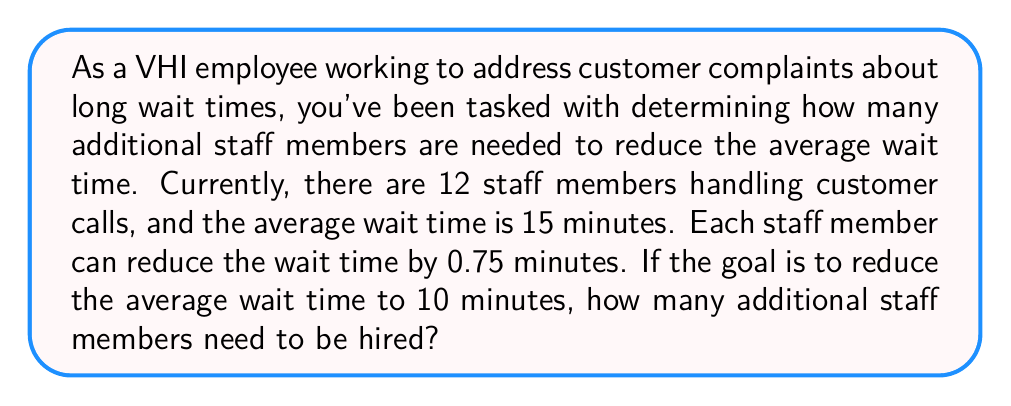Can you answer this question? Let's approach this step-by-step:

1. Define variables:
   Let $x$ = number of additional staff members needed

2. Calculate the total reduction in wait time needed:
   Current wait time - Desired wait time = $15 - 10 = 5$ minutes

3. Set up an equation:
   Each staff member reduces wait time by 0.75 minutes, so:
   $$0.75x = 5$$

4. Solve the equation:
   $$x = \frac{5}{0.75} = \frac{20}{3} = 6.67$$

5. Since we can't hire a fractional number of staff members, we need to round up to the nearest whole number.
Answer: 7 additional staff members need to be hired. 